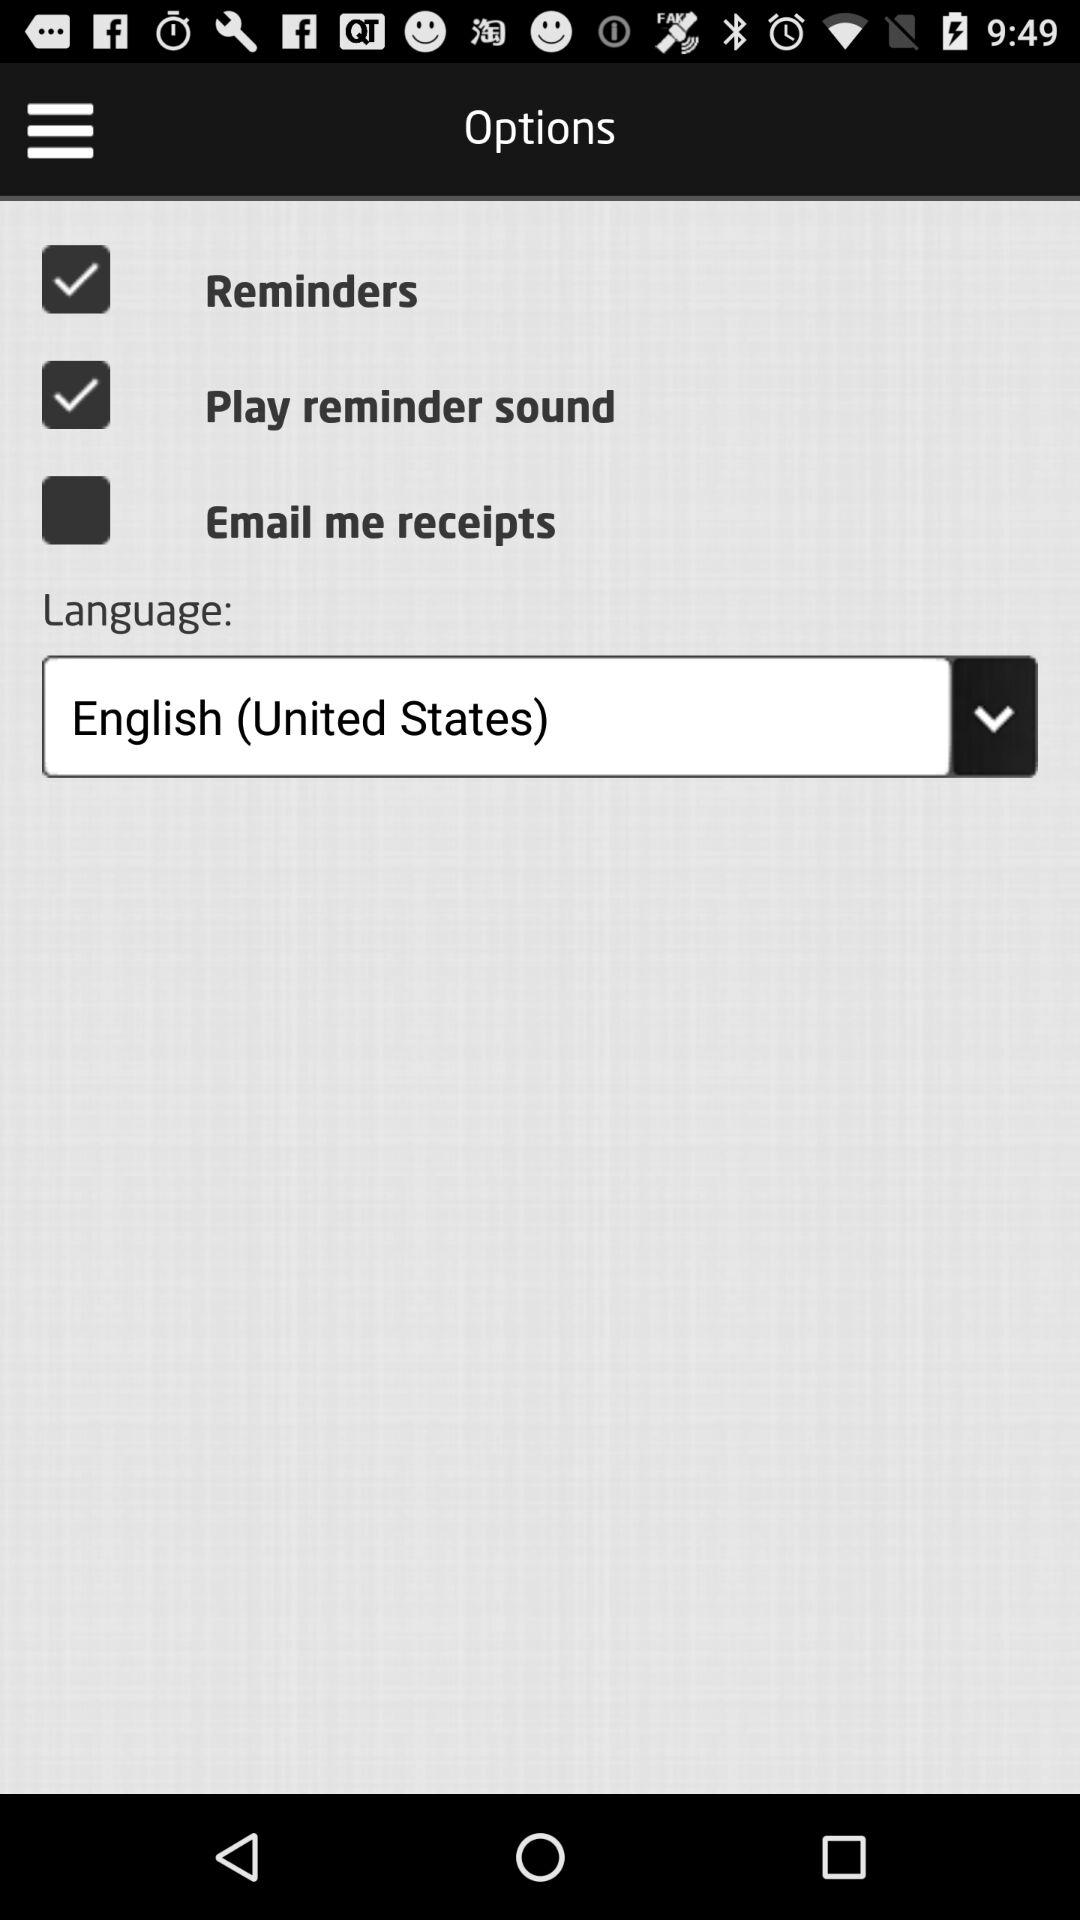What is the selected language? The selected language is English (United States). 